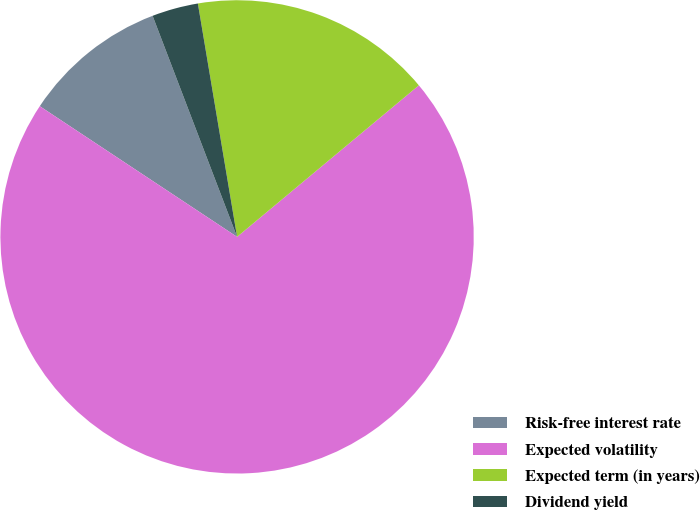Convert chart to OTSL. <chart><loc_0><loc_0><loc_500><loc_500><pie_chart><fcel>Risk-free interest rate<fcel>Expected volatility<fcel>Expected term (in years)<fcel>Dividend yield<nl><fcel>9.88%<fcel>70.37%<fcel>16.59%<fcel>3.16%<nl></chart> 